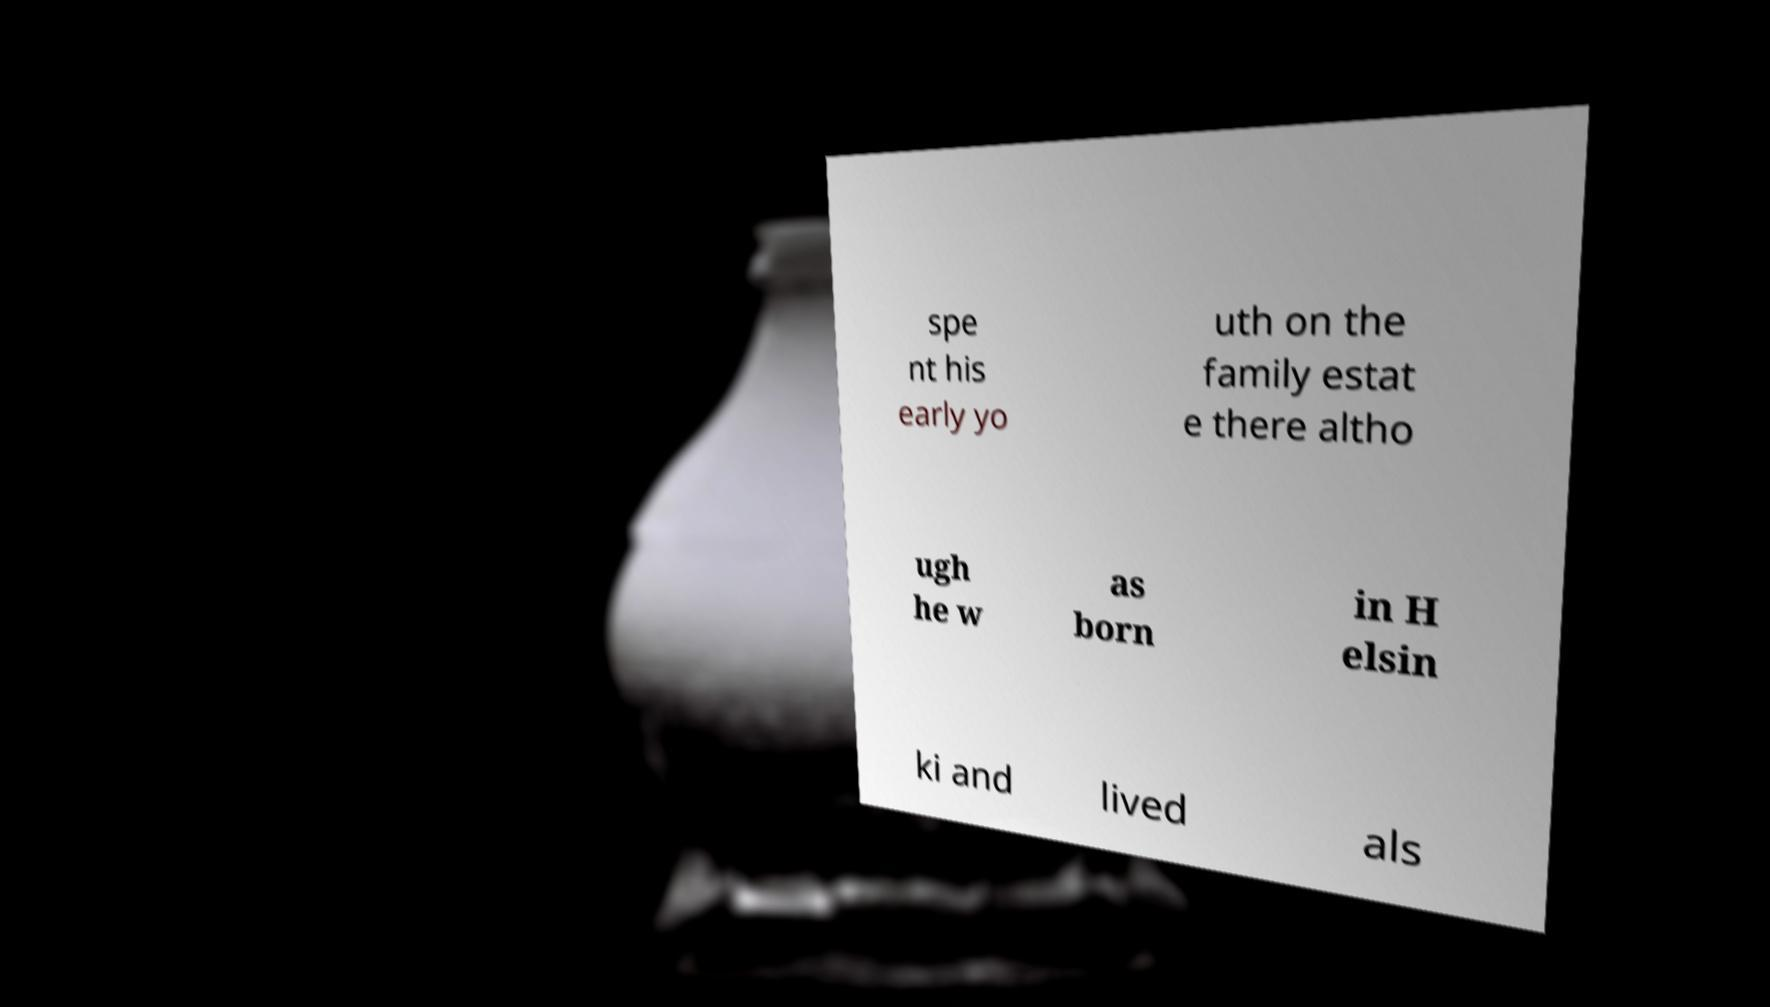Can you accurately transcribe the text from the provided image for me? spe nt his early yo uth on the family estat e there altho ugh he w as born in H elsin ki and lived als 